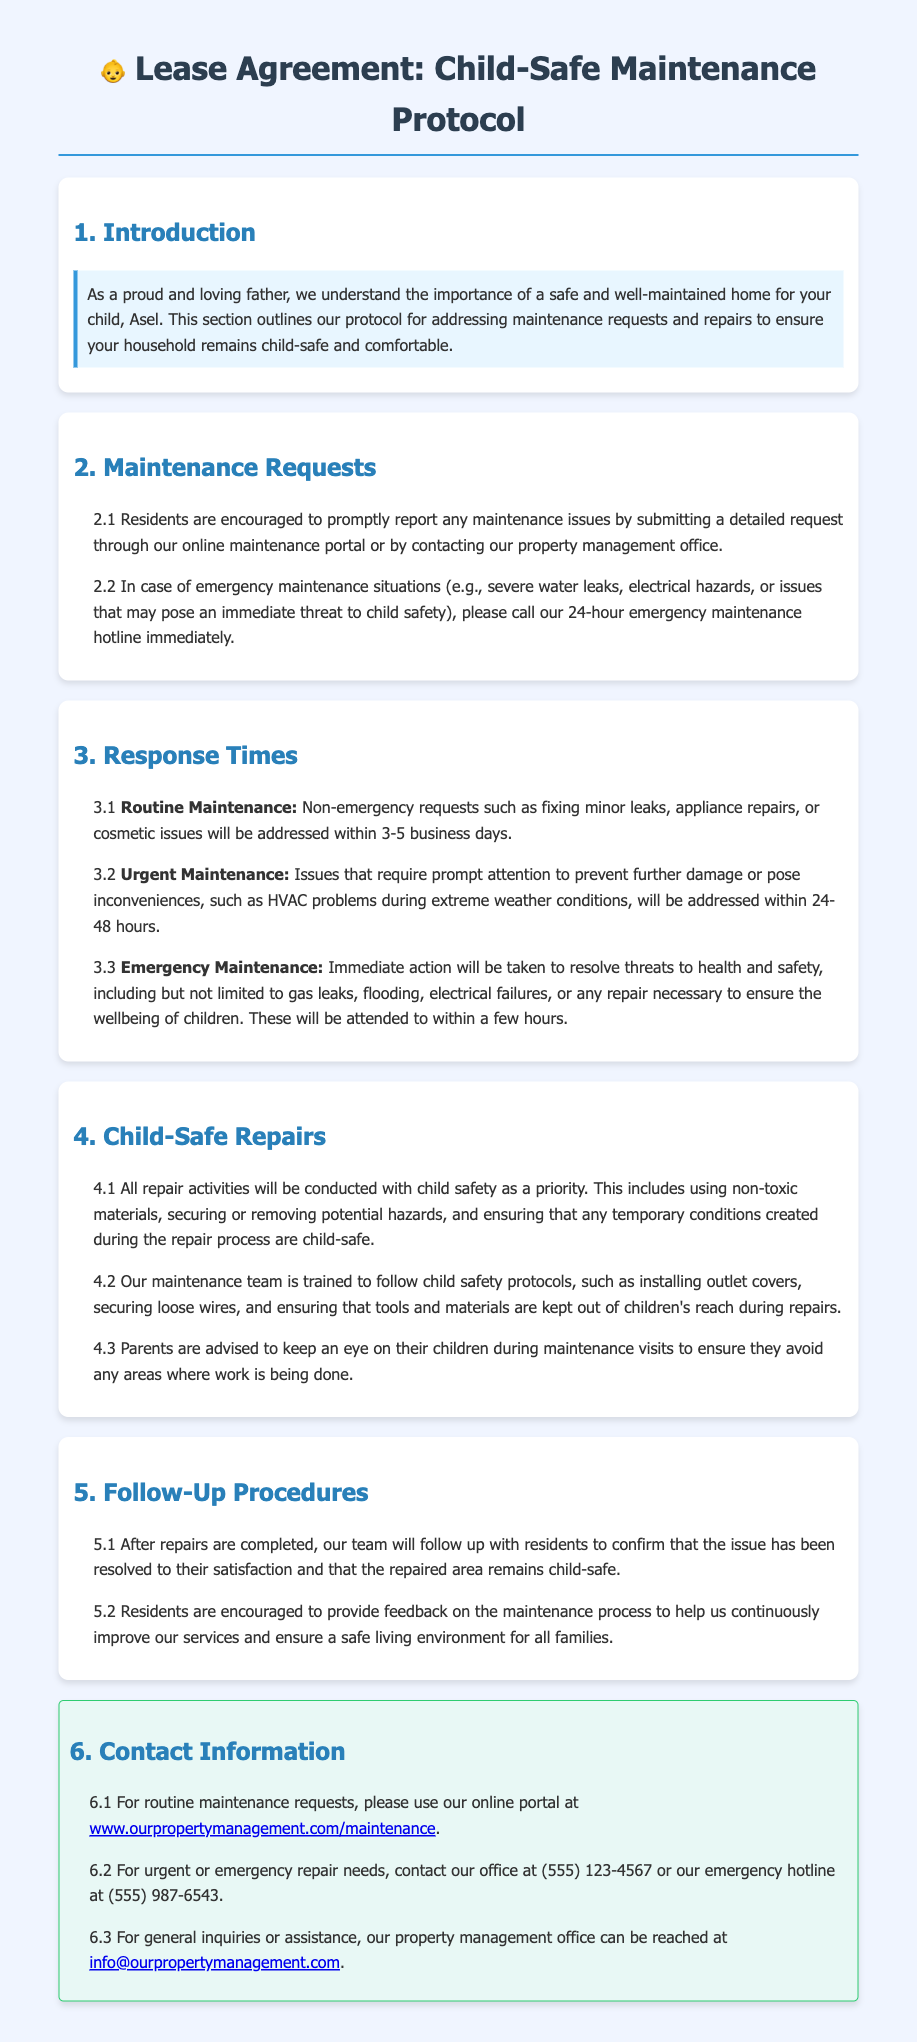What are the ways to submit maintenance requests? The document states that residents can submit requests through the online maintenance portal or by contacting the property management office.
Answer: Online maintenance portal or contacting the property management office What is the response time for routine maintenance requests? The document specifies that routine maintenance requests will be addressed within 3-5 business days.
Answer: 3-5 business days What should you do in case of an emergency maintenance situation? The document advises residents to call the 24-hour emergency maintenance hotline immediately.
Answer: Call the 24-hour emergency maintenance hotline What types of repairs prioritize child safety? The document indicates that all repair activities are conducted with child safety as a priority.
Answer: All repair activities What is the follow-up procedure after repairs are completed? According to the document, the team will follow up with residents to confirm satisfaction and child-safety of the repaired area.
Answer: Follow up to confirm satisfaction and child-safety Which hotline should be used for urgent repair needs? The document provides the emergency hotline number for urgent repairs, which is listed as (555) 987-6543.
Answer: (555) 987-6543 What does the maintenance team ensure during repairs? The document mentions that the maintenance team is trained to follow child safety protocols during repairs.
Answer: Child safety protocols How quickly are emergency maintenance issues addressed? The document states that emergency maintenance issues will be attended to within a few hours.
Answer: A few hours 